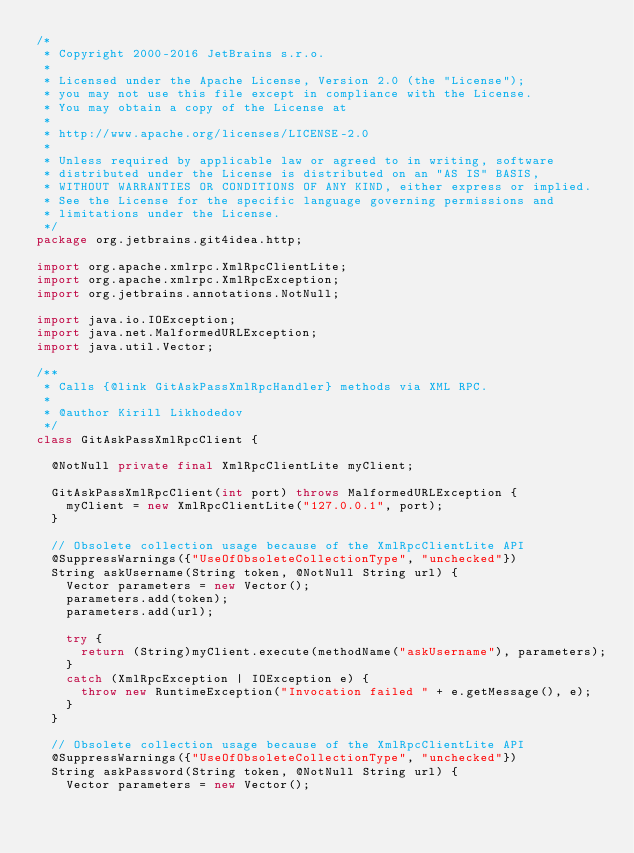Convert code to text. <code><loc_0><loc_0><loc_500><loc_500><_Java_>/*
 * Copyright 2000-2016 JetBrains s.r.o.
 *
 * Licensed under the Apache License, Version 2.0 (the "License");
 * you may not use this file except in compliance with the License.
 * You may obtain a copy of the License at
 *
 * http://www.apache.org/licenses/LICENSE-2.0
 *
 * Unless required by applicable law or agreed to in writing, software
 * distributed under the License is distributed on an "AS IS" BASIS,
 * WITHOUT WARRANTIES OR CONDITIONS OF ANY KIND, either express or implied.
 * See the License for the specific language governing permissions and
 * limitations under the License.
 */
package org.jetbrains.git4idea.http;

import org.apache.xmlrpc.XmlRpcClientLite;
import org.apache.xmlrpc.XmlRpcException;
import org.jetbrains.annotations.NotNull;

import java.io.IOException;
import java.net.MalformedURLException;
import java.util.Vector;

/**
 * Calls {@link GitAskPassXmlRpcHandler} methods via XML RPC.
 *
 * @author Kirill Likhodedov
 */
class GitAskPassXmlRpcClient {

  @NotNull private final XmlRpcClientLite myClient;

  GitAskPassXmlRpcClient(int port) throws MalformedURLException {
    myClient = new XmlRpcClientLite("127.0.0.1", port);
  }

  // Obsolete collection usage because of the XmlRpcClientLite API
  @SuppressWarnings({"UseOfObsoleteCollectionType", "unchecked"})
  String askUsername(String token, @NotNull String url) {
    Vector parameters = new Vector();
    parameters.add(token);
    parameters.add(url);

    try {
      return (String)myClient.execute(methodName("askUsername"), parameters);
    }
    catch (XmlRpcException | IOException e) {
      throw new RuntimeException("Invocation failed " + e.getMessage(), e);
    }
  }

  // Obsolete collection usage because of the XmlRpcClientLite API
  @SuppressWarnings({"UseOfObsoleteCollectionType", "unchecked"})
  String askPassword(String token, @NotNull String url) {
    Vector parameters = new Vector();</code> 